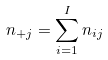Convert formula to latex. <formula><loc_0><loc_0><loc_500><loc_500>n _ { + j } = \sum _ { i = 1 } ^ { I } n _ { i j }</formula> 